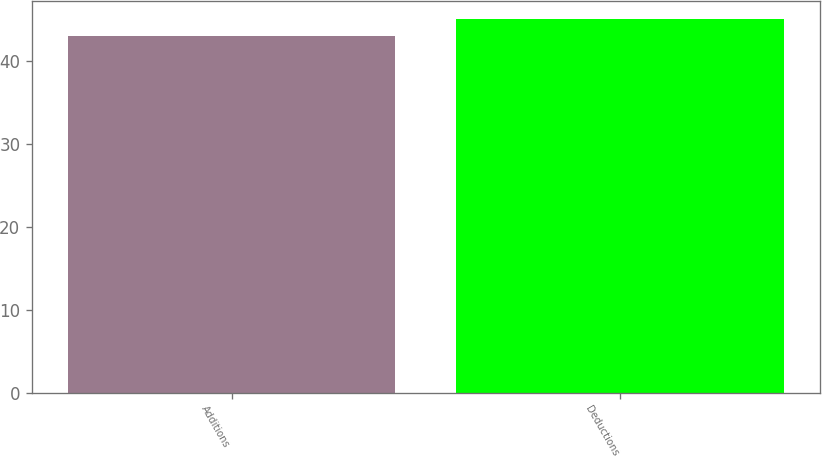Convert chart. <chart><loc_0><loc_0><loc_500><loc_500><bar_chart><fcel>Additions<fcel>Deductions<nl><fcel>43<fcel>45<nl></chart> 